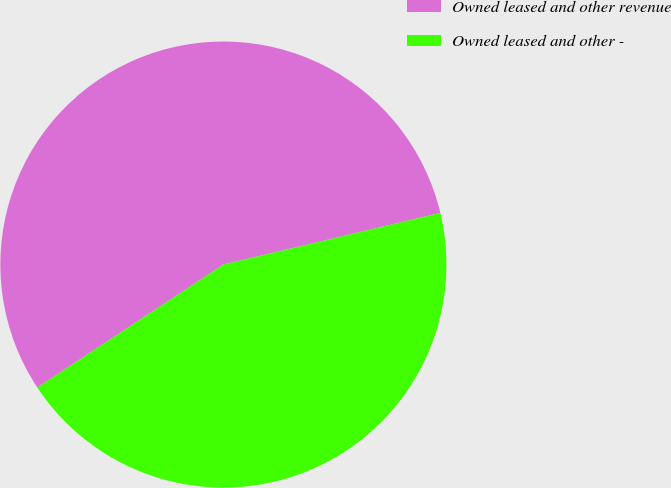Convert chart. <chart><loc_0><loc_0><loc_500><loc_500><pie_chart><fcel>Owned leased and other revenue<fcel>Owned leased and other -<nl><fcel>55.58%<fcel>44.42%<nl></chart> 